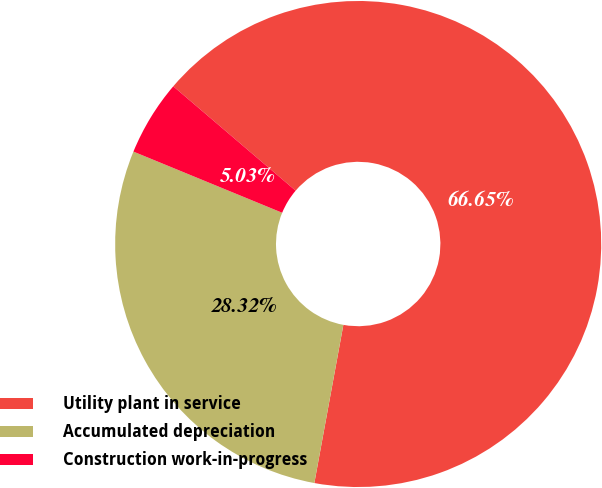Convert chart. <chart><loc_0><loc_0><loc_500><loc_500><pie_chart><fcel>Utility plant in service<fcel>Accumulated depreciation<fcel>Construction work-in-progress<nl><fcel>66.65%<fcel>28.32%<fcel>5.03%<nl></chart> 